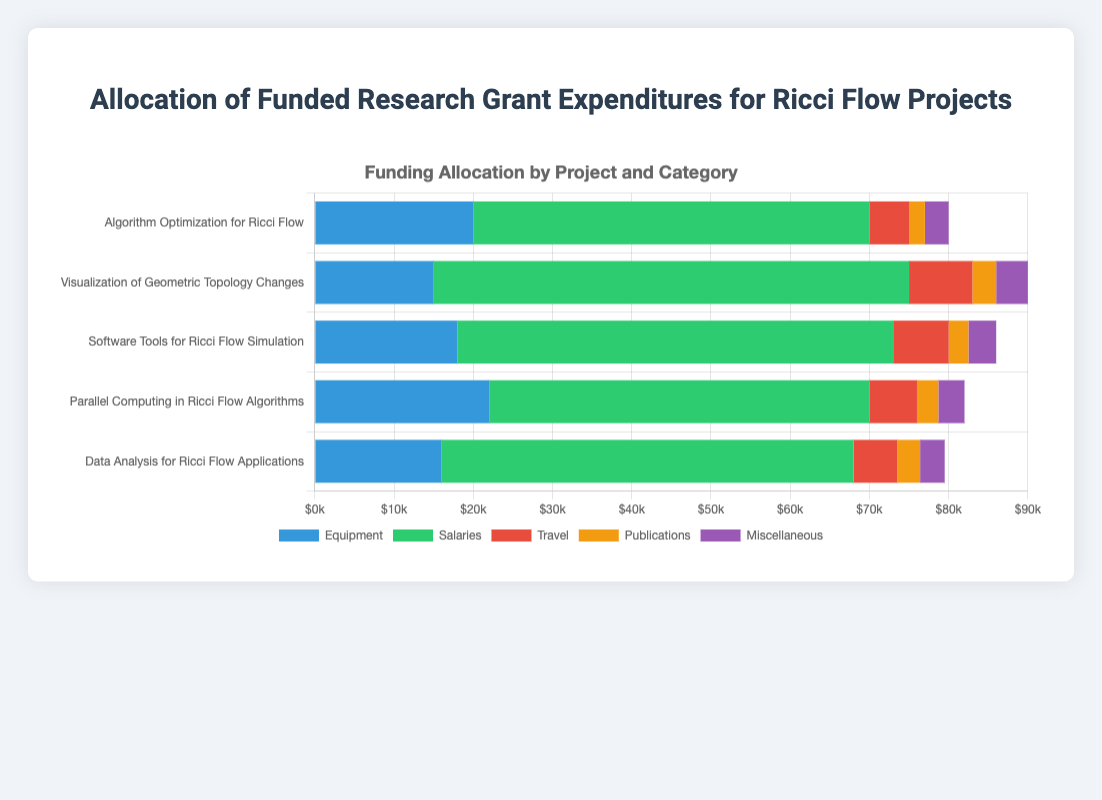What is the total funding allocated for the project "Algorithm Optimization for Ricci Flow"? To find the total funding, sum all the categories for "Algorithm Optimization for Ricci Flow": Equipment ($20,000) + Salaries ($50,000) + Travel ($5,000) + Publications ($2,000) + Miscellaneous ($3,000) = $80,000
Answer: $80,000 Which project has the highest allocation for salaries? Compare the salary allocations for all projects. The values are: "Algorithm Optimization for Ricci Flow" ($50,000), "Visualization of Geometric Topology Changes" ($60,000), "Software Tools for Ricci Flow Simulation" ($55,000), "Parallel Computing in Ricci Flow Algorithms" ($48,000), and "Data Analysis for Ricci Flow Applications" ($52,000). The highest value is $60,000 for "Visualization of Geometric Topology Changes"
Answer: "Visualization of Geometric Topology Changes" Which expenditure category has the highest total funding across all projects? Sum the funding for each category across all projects: Equipment: $90,000, Salaries: $265,000, Travel: $31,500, Publications: $13,100, Miscellaneous: $16,900. Salaries have the highest total funding
Answer: Salaries What is the average funding allocated for equipment across all projects? The total funding for equipment across all projects is $90,000 (sum of $20,000, $15,000, $18,000, $22,000, $16,000). There are 5 projects, so the average is $90,000 / 5 = $18,000
Answer: $18,000 By how much does the travel funding for "Visualization of Geometric Topology Changes" exceed the travel funding for "Algorithm Optimization for Ricci Flow"? Travel funding for "Visualization of Geometric Topology Changes" is $8,000, for "Algorithm Optimization for Ricci Flow" is $5,000. The difference is $8,000 - $5,000 = $3,000
Answer: $3,000 How much more is allocated to equipment compared to publications for "Parallel Computing in Ricci Flow Algorithms"? Equipment funding is $22,000 and publications funding is $2,700 for "Parallel Computing in Ricci Flow Algorithms". The difference is $22,000 - $2,700 = $19,300
Answer: $19,300 Which project has the lowest combined total for travel and miscellaneous expenses? Calculate the combined funding for travel and miscellaneous for each project: "Algorithm Optimization for Ricci Flow" ($5,000 + $3,000 = $8,000), "Visualization of Geometric Topology Changes" ($8,000 + $4,000 = $12,000), "Software Tools for Ricci Flow Simulation" ($7,000 + $3,500 = $10,500), "Parallel Computing in Ricci Flow Algorithms" ($6,000 + $3,300 = $9,300), and "Data Analysis for Ricci Flow Applications" ($5,500 + $3,100 = $8,600). The lowest combined total is $8,000 for "Algorithm Optimization for Ricci Flow"
Answer: "Algorithm Optimization for Ricci Flow" Which project allocated the highest amount to equipment, and what is the amount? Compare the equipment allocations for each project: "Algorithm Optimization for Ricci Flow" ($20,000), "Visualization of Geometric Topology Changes" ($15,000), "Software Tools for Ricci Flow Simulation" ($18,000), "Parallel Computing in Ricci Flow Algorithms" ($22,000), and "Data Analysis for Ricci Flow Applications" ($16,000). The highest allocation is $22,000 for "Parallel Computing in Ricci Flow Algorithms"
Answer: "Parallel Computing in Ricci Flow Algorithms", $22,000 What is the total funding allocated for publications across all projects? Sum the funding for publications for all projects: $2,000 (Algorithm Optimization), $3,000 (Visualization of Geometric Topology Changes), $2,500 (Software Tools for Ricci Flow Simulation), $2,700 (Parallel Computing in Ricci Flow Algorithms), and $2,900 (Data Analysis for Ricci Flow Applications). The total is $2,000 + $3,000 + $2,500 + $2,700 + $2,900 = $13,100
Answer: $13,100 